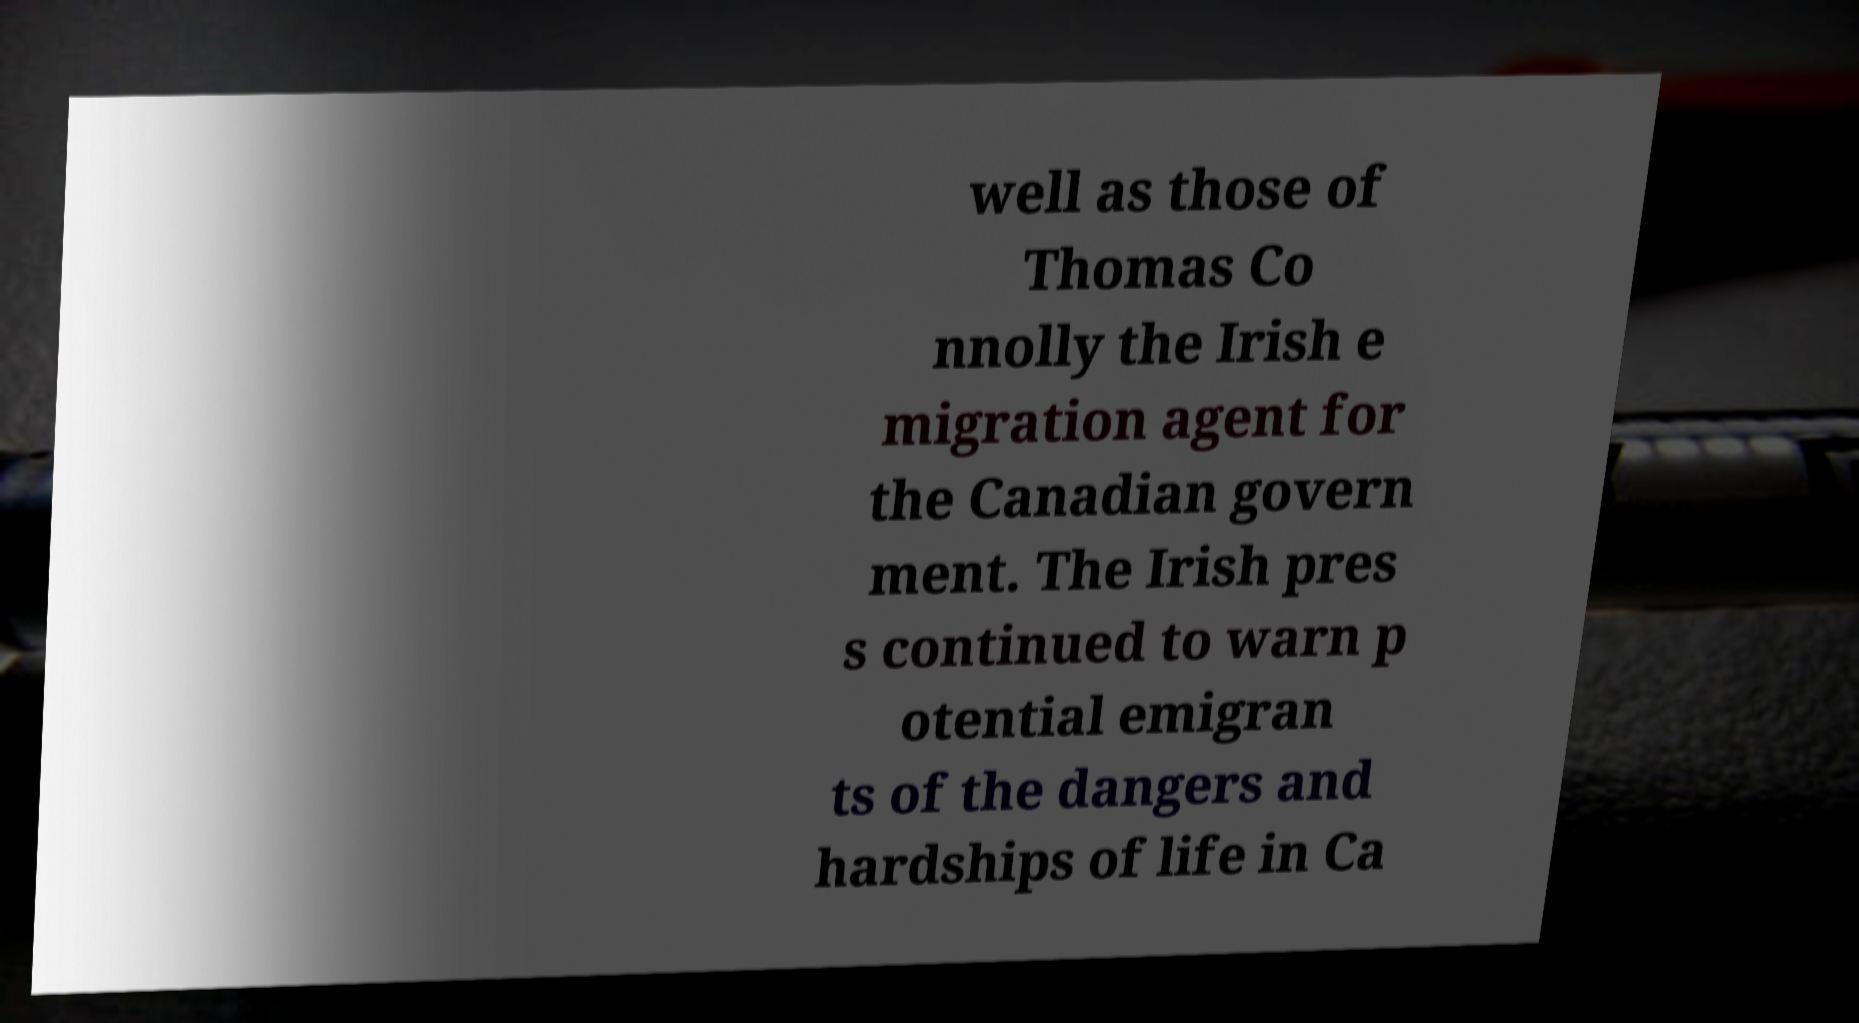For documentation purposes, I need the text within this image transcribed. Could you provide that? well as those of Thomas Co nnolly the Irish e migration agent for the Canadian govern ment. The Irish pres s continued to warn p otential emigran ts of the dangers and hardships of life in Ca 